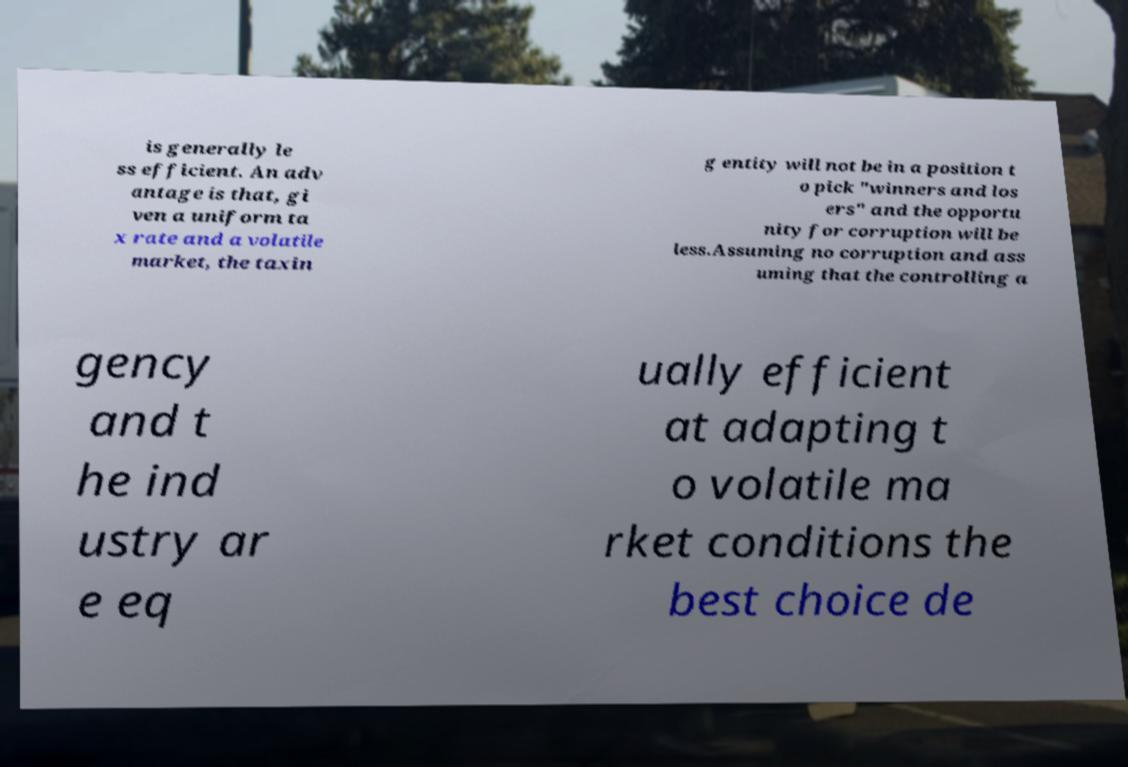Can you read and provide the text displayed in the image?This photo seems to have some interesting text. Can you extract and type it out for me? is generally le ss efficient. An adv antage is that, gi ven a uniform ta x rate and a volatile market, the taxin g entity will not be in a position t o pick "winners and los ers" and the opportu nity for corruption will be less.Assuming no corruption and ass uming that the controlling a gency and t he ind ustry ar e eq ually efficient at adapting t o volatile ma rket conditions the best choice de 